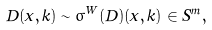<formula> <loc_0><loc_0><loc_500><loc_500>D ( x , k ) \sim \sigma ^ { W } ( \hat { D } ) ( x , k ) \in S ^ { m } ,</formula> 